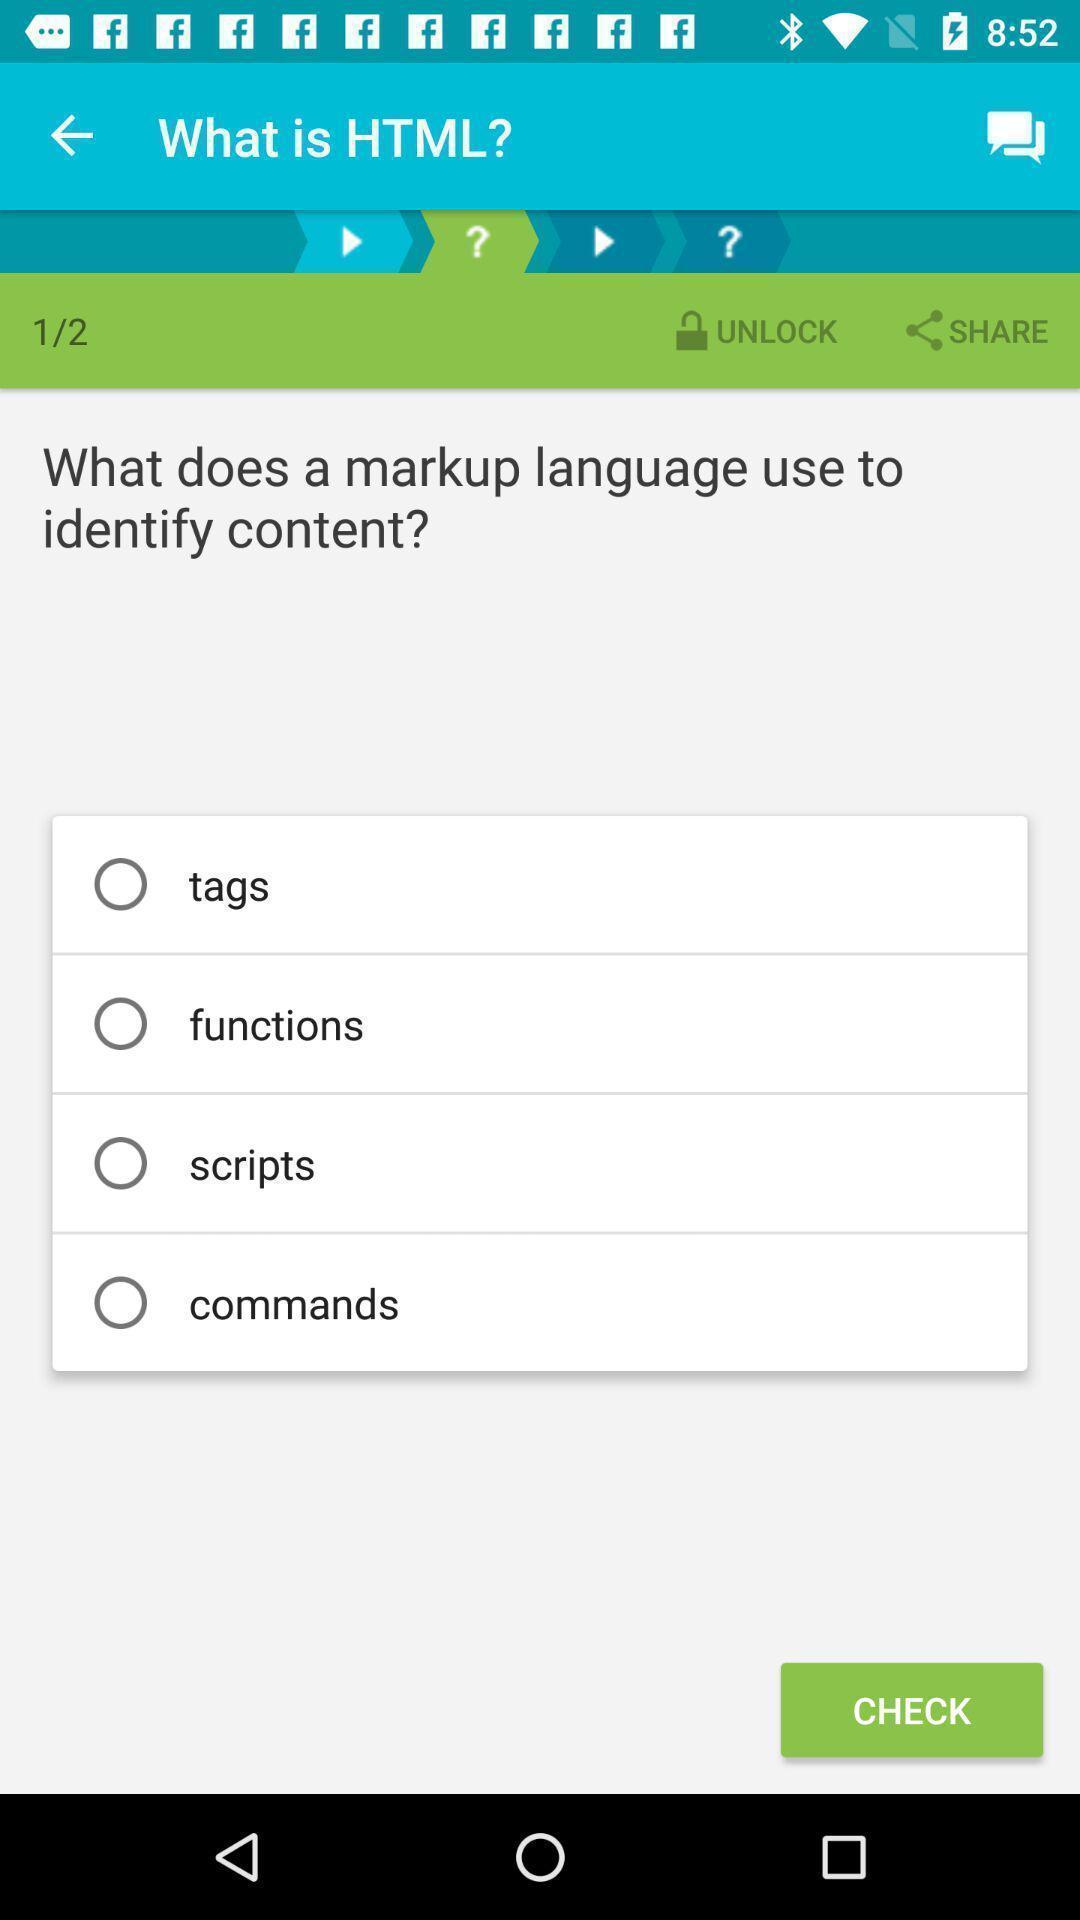Summarize the information in this screenshot. Screen shows details of learning app. 